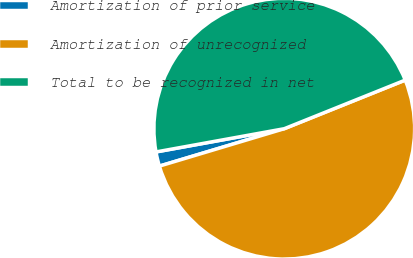<chart> <loc_0><loc_0><loc_500><loc_500><pie_chart><fcel>Amortization of prior service<fcel>Amortization of unrecognized<fcel>Total to be recognized in net<nl><fcel>1.78%<fcel>51.45%<fcel>46.77%<nl></chart> 